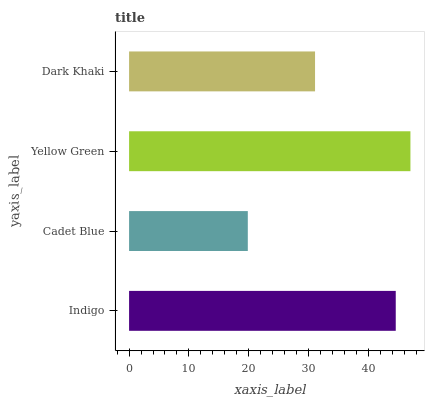Is Cadet Blue the minimum?
Answer yes or no. Yes. Is Yellow Green the maximum?
Answer yes or no. Yes. Is Yellow Green the minimum?
Answer yes or no. No. Is Cadet Blue the maximum?
Answer yes or no. No. Is Yellow Green greater than Cadet Blue?
Answer yes or no. Yes. Is Cadet Blue less than Yellow Green?
Answer yes or no. Yes. Is Cadet Blue greater than Yellow Green?
Answer yes or no. No. Is Yellow Green less than Cadet Blue?
Answer yes or no. No. Is Indigo the high median?
Answer yes or no. Yes. Is Dark Khaki the low median?
Answer yes or no. Yes. Is Cadet Blue the high median?
Answer yes or no. No. Is Cadet Blue the low median?
Answer yes or no. No. 